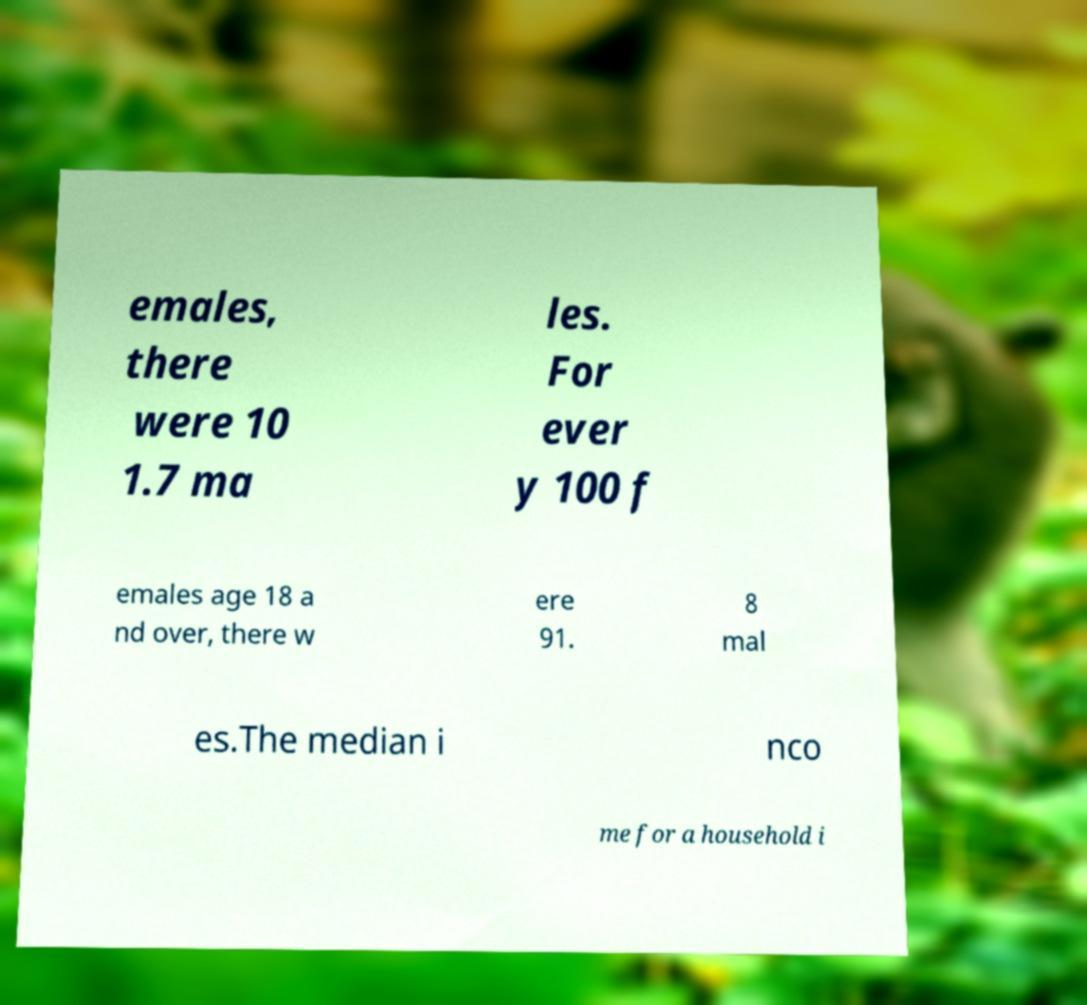Could you assist in decoding the text presented in this image and type it out clearly? emales, there were 10 1.7 ma les. For ever y 100 f emales age 18 a nd over, there w ere 91. 8 mal es.The median i nco me for a household i 